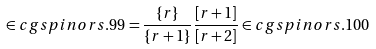<formula> <loc_0><loc_0><loc_500><loc_500>\in c g { s p i n o r s . 9 9 } = \frac { \{ r \} } { \{ r + 1 \} } \frac { [ r + 1 ] } { [ r + 2 ] } \in c g { s p i n o r s . 1 0 0 }</formula> 